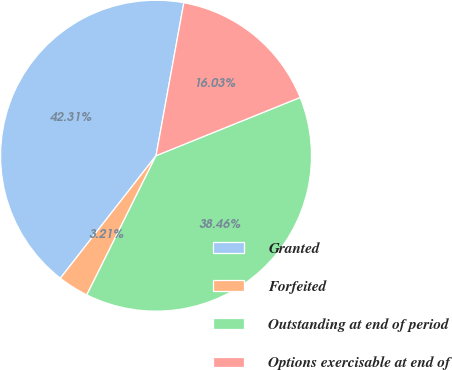Convert chart. <chart><loc_0><loc_0><loc_500><loc_500><pie_chart><fcel>Granted<fcel>Forfeited<fcel>Outstanding at end of period<fcel>Options exercisable at end of<nl><fcel>42.31%<fcel>3.21%<fcel>38.46%<fcel>16.03%<nl></chart> 